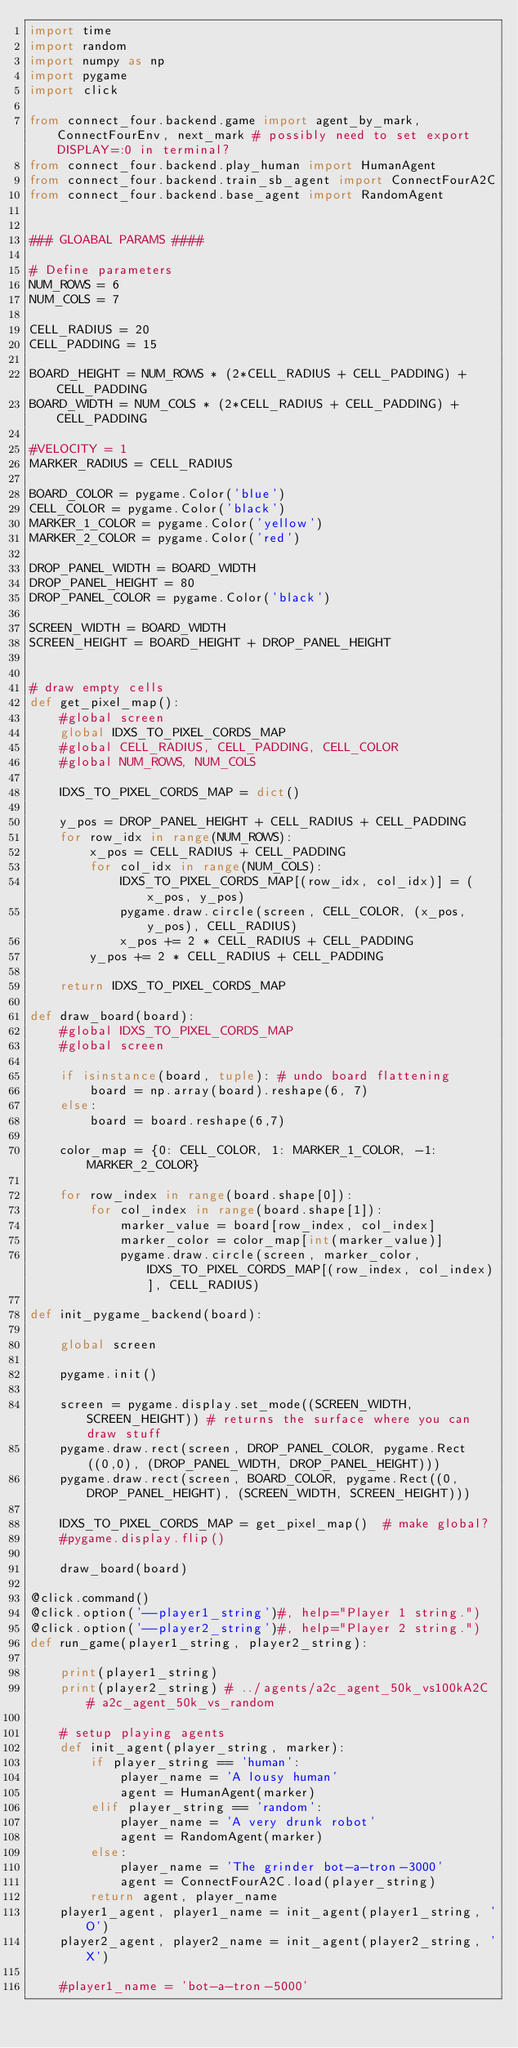<code> <loc_0><loc_0><loc_500><loc_500><_Python_>import time
import random
import numpy as np
import pygame
import click

from connect_four.backend.game import agent_by_mark, ConnectFourEnv, next_mark # possibly need to set export DISPLAY=:0 in terminal?
from connect_four.backend.play_human import HumanAgent
from connect_four.backend.train_sb_agent import ConnectFourA2C
from connect_four.backend.base_agent import RandomAgent


### GLOABAL PARAMS ####

# Define parameters
NUM_ROWS = 6
NUM_COLS = 7

CELL_RADIUS = 20
CELL_PADDING = 15

BOARD_HEIGHT = NUM_ROWS * (2*CELL_RADIUS + CELL_PADDING) + CELL_PADDING
BOARD_WIDTH = NUM_COLS * (2*CELL_RADIUS + CELL_PADDING) + CELL_PADDING

#VELOCITY = 1
MARKER_RADIUS = CELL_RADIUS

BOARD_COLOR = pygame.Color('blue')
CELL_COLOR = pygame.Color('black')
MARKER_1_COLOR = pygame.Color('yellow')
MARKER_2_COLOR = pygame.Color('red')

DROP_PANEL_WIDTH = BOARD_WIDTH
DROP_PANEL_HEIGHT = 80
DROP_PANEL_COLOR = pygame.Color('black')

SCREEN_WIDTH = BOARD_WIDTH
SCREEN_HEIGHT = BOARD_HEIGHT + DROP_PANEL_HEIGHT


# draw empty cells
def get_pixel_map():
    #global screen
    global IDXS_TO_PIXEL_CORDS_MAP
    #global CELL_RADIUS, CELL_PADDING, CELL_COLOR
    #global NUM_ROWS, NUM_COLS
    
    IDXS_TO_PIXEL_CORDS_MAP = dict()

    y_pos = DROP_PANEL_HEIGHT + CELL_RADIUS + CELL_PADDING
    for row_idx in range(NUM_ROWS):
        x_pos = CELL_RADIUS + CELL_PADDING
        for col_idx in range(NUM_COLS):
            IDXS_TO_PIXEL_CORDS_MAP[(row_idx, col_idx)] = (x_pos, y_pos)
            pygame.draw.circle(screen, CELL_COLOR, (x_pos, y_pos), CELL_RADIUS)
            x_pos += 2 * CELL_RADIUS + CELL_PADDING
        y_pos += 2 * CELL_RADIUS + CELL_PADDING
    
    return IDXS_TO_PIXEL_CORDS_MAP

def draw_board(board):
    #global IDXS_TO_PIXEL_CORDS_MAP
    #global screen
    
    if isinstance(board, tuple): # undo board flattening
        board = np.array(board).reshape(6, 7)
    else:
        board = board.reshape(6,7)
        
    color_map = {0: CELL_COLOR, 1: MARKER_1_COLOR, -1: MARKER_2_COLOR}
    
    for row_index in range(board.shape[0]):
        for col_index in range(board.shape[1]):            
            marker_value = board[row_index, col_index]
            marker_color = color_map[int(marker_value)]
            pygame.draw.circle(screen, marker_color, IDXS_TO_PIXEL_CORDS_MAP[(row_index, col_index)], CELL_RADIUS)

def init_pygame_backend(board):

    global screen

    pygame.init()

    screen = pygame.display.set_mode((SCREEN_WIDTH, SCREEN_HEIGHT)) # returns the surface where you can draw stuff
    pygame.draw.rect(screen, DROP_PANEL_COLOR, pygame.Rect((0,0), (DROP_PANEL_WIDTH, DROP_PANEL_HEIGHT)))
    pygame.draw.rect(screen, BOARD_COLOR, pygame.Rect((0,DROP_PANEL_HEIGHT), (SCREEN_WIDTH, SCREEN_HEIGHT)))

    IDXS_TO_PIXEL_CORDS_MAP = get_pixel_map()  # make global?
    #pygame.display.flip()

    draw_board(board)

@click.command()
@click.option('--player1_string')#, help="Player 1 string.")
@click.option('--player2_string')#, help="Player 2 string.") 
def run_game(player1_string, player2_string):

    print(player1_string)
    print(player2_string) # ../agents/a2c_agent_50k_vs100kA2C # a2c_agent_50k_vs_random

    # setup playing agents
    def init_agent(player_string, marker):
        if player_string == 'human':
            player_name = 'A lousy human'
            agent = HumanAgent(marker)
        elif player_string == 'random':
            player_name = 'A very drunk robot'
            agent = RandomAgent(marker)
        else:
            player_name = 'The grinder bot-a-tron-3000'
            agent = ConnectFourA2C.load(player_string)
        return agent, player_name
    player1_agent, player1_name = init_agent(player1_string, 'O')
    player2_agent, player2_name = init_agent(player2_string, 'X')

    #player1_name = 'bot-a-tron-5000'</code> 